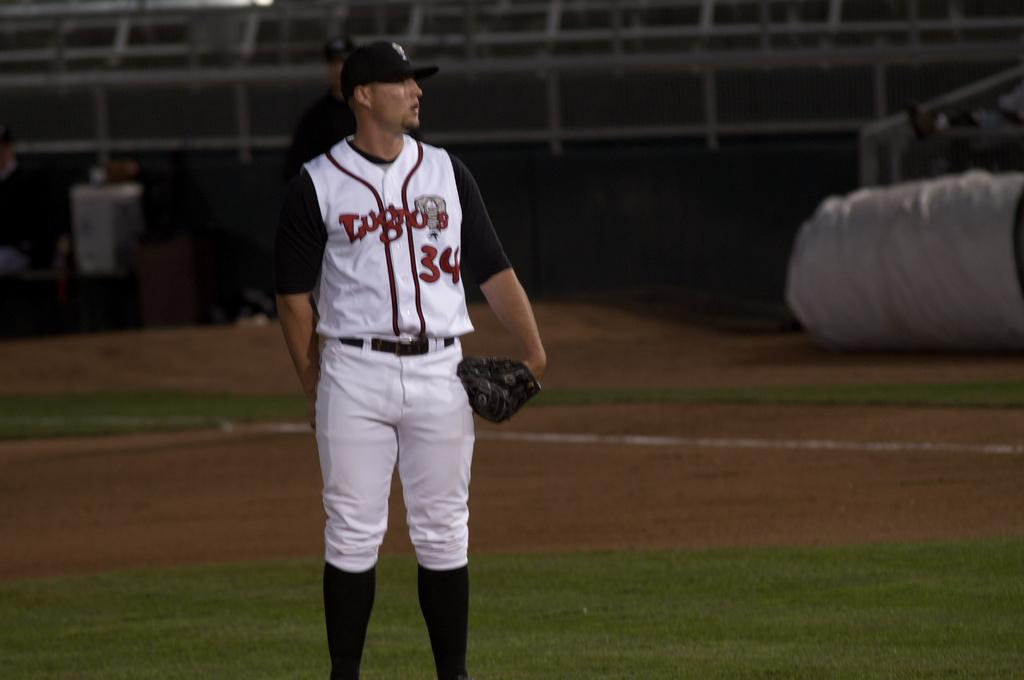<image>
Relay a brief, clear account of the picture shown. A baseball player in a black, red and white uniform with the number 34 and team name on his jersey stands on the field. 